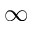Convert formula to latex. <formula><loc_0><loc_0><loc_500><loc_500>\infty</formula> 